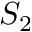Convert formula to latex. <formula><loc_0><loc_0><loc_500><loc_500>S _ { 2 }</formula> 